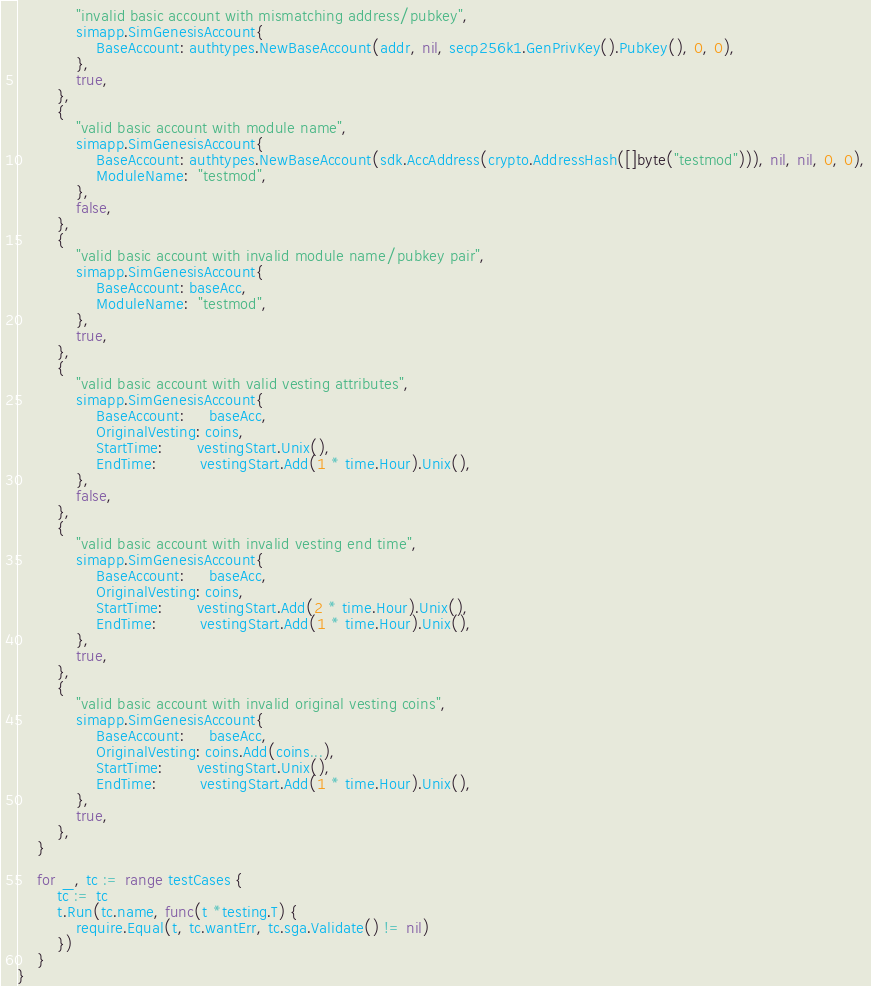<code> <loc_0><loc_0><loc_500><loc_500><_Go_>			"invalid basic account with mismatching address/pubkey",
			simapp.SimGenesisAccount{
				BaseAccount: authtypes.NewBaseAccount(addr, nil, secp256k1.GenPrivKey().PubKey(), 0, 0),
			},
			true,
		},
		{
			"valid basic account with module name",
			simapp.SimGenesisAccount{
				BaseAccount: authtypes.NewBaseAccount(sdk.AccAddress(crypto.AddressHash([]byte("testmod"))), nil, nil, 0, 0),
				ModuleName:  "testmod",
			},
			false,
		},
		{
			"valid basic account with invalid module name/pubkey pair",
			simapp.SimGenesisAccount{
				BaseAccount: baseAcc,
				ModuleName:  "testmod",
			},
			true,
		},
		{
			"valid basic account with valid vesting attributes",
			simapp.SimGenesisAccount{
				BaseAccount:     baseAcc,
				OriginalVesting: coins,
				StartTime:       vestingStart.Unix(),
				EndTime:         vestingStart.Add(1 * time.Hour).Unix(),
			},
			false,
		},
		{
			"valid basic account with invalid vesting end time",
			simapp.SimGenesisAccount{
				BaseAccount:     baseAcc,
				OriginalVesting: coins,
				StartTime:       vestingStart.Add(2 * time.Hour).Unix(),
				EndTime:         vestingStart.Add(1 * time.Hour).Unix(),
			},
			true,
		},
		{
			"valid basic account with invalid original vesting coins",
			simapp.SimGenesisAccount{
				BaseAccount:     baseAcc,
				OriginalVesting: coins.Add(coins...),
				StartTime:       vestingStart.Unix(),
				EndTime:         vestingStart.Add(1 * time.Hour).Unix(),
			},
			true,
		},
	}

	for _, tc := range testCases {
		tc := tc
		t.Run(tc.name, func(t *testing.T) {
			require.Equal(t, tc.wantErr, tc.sga.Validate() != nil)
		})
	}
}
</code> 